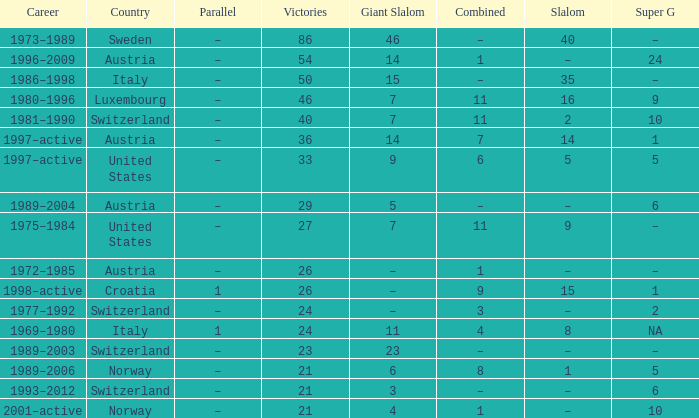What Career has a Super G of 5, and a Combined of 6? 1997–active. 